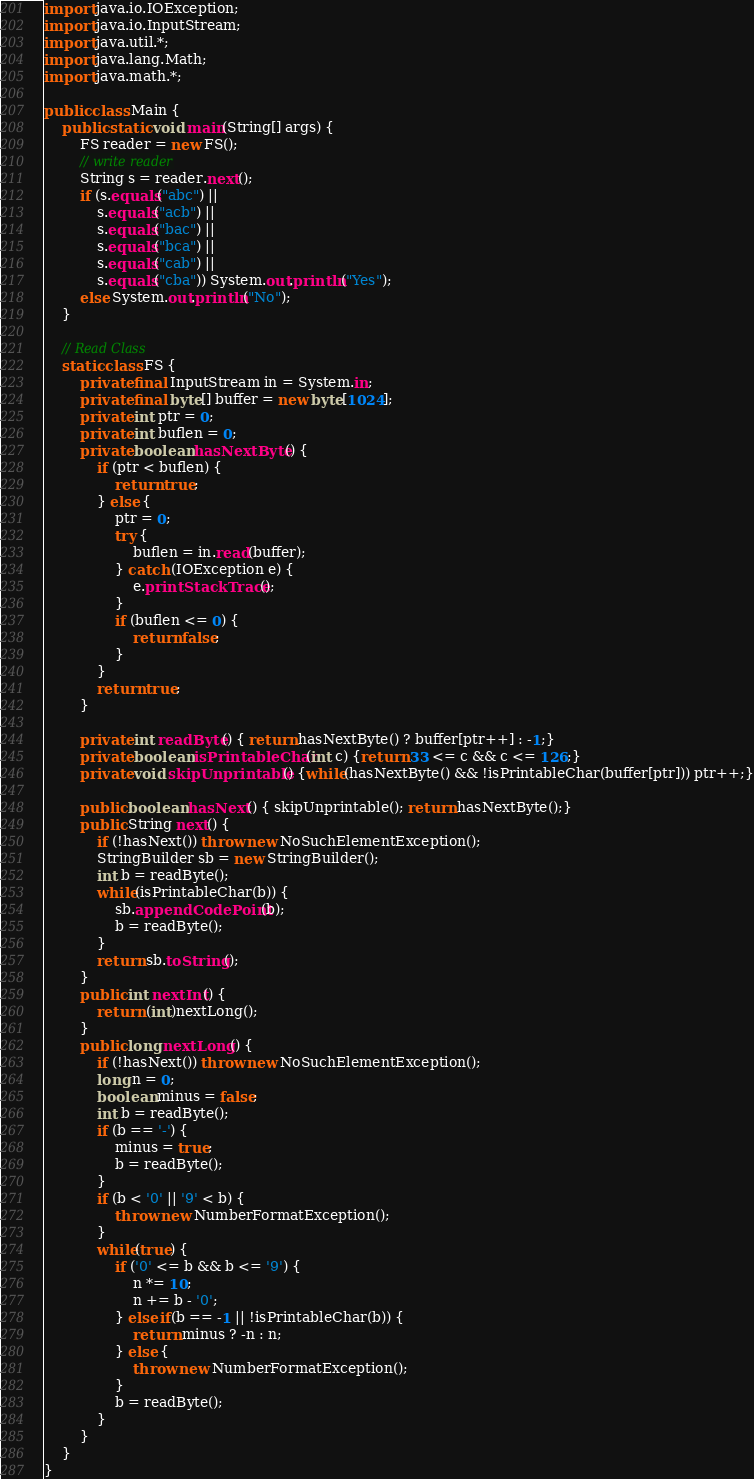Convert code to text. <code><loc_0><loc_0><loc_500><loc_500><_Java_>import java.io.IOException;
import java.io.InputStream;
import java.util.*;
import java.lang.Math;
import java.math.*;

public class Main {
    public static void main(String[] args) {
        FS reader = new FS();
        // write reader
        String s = reader.next();
        if (s.equals("abc") ||
            s.equals("acb") ||
            s.equals("bac") ||
            s.equals("bca") ||
            s.equals("cab") ||
            s.equals("cba")) System.out.println("Yes");
        else System.out.println("No");
    }

    // Read Class
    static class FS {
        private final InputStream in = System.in;
        private final byte[] buffer = new byte[1024];
        private int ptr = 0;
        private int buflen = 0;
        private boolean hasNextByte() {
            if (ptr < buflen) {
                return true;
            } else {
                ptr = 0;
                try {
                    buflen = in.read(buffer);
                } catch (IOException e) {
                    e.printStackTrace();
                }
                if (buflen <= 0) {
                    return false;
                }
            }
            return true;
        }
    
        private int readByte() { return hasNextByte() ? buffer[ptr++] : -1;}
        private boolean isPrintableChar(int c) {return 33 <= c && c <= 126;}
        private void skipUnprintable() {while(hasNextByte() && !isPrintableChar(buffer[ptr])) ptr++;}
    
        public boolean hasNext() { skipUnprintable(); return hasNextByte();}
        public String next() {
            if (!hasNext()) throw new NoSuchElementException();
            StringBuilder sb = new StringBuilder();
            int b = readByte();
            while(isPrintableChar(b)) {
                sb.appendCodePoint(b);
                b = readByte();
            }
            return sb.toString();
        }
        public int nextInt() {
            return (int)nextLong();
        }
        public long nextLong() {
            if (!hasNext()) throw new NoSuchElementException();
            long n = 0;
            boolean minus = false;
            int b = readByte();
            if (b == '-') {
                minus = true;
                b = readByte();
            }
            if (b < '0' || '9' < b) {
                throw new NumberFormatException();
            }
            while(true) {
                if ('0' <= b && b <= '9') {
                    n *= 10;
                    n += b - '0';
                } else if(b == -1 || !isPrintableChar(b)) {
                    return minus ? -n : n;
                } else {
                    throw new NumberFormatException();
                }
                b = readByte();
            }
        }
    }
}

</code> 